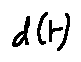Convert formula to latex. <formula><loc_0><loc_0><loc_500><loc_500>d ( t )</formula> 